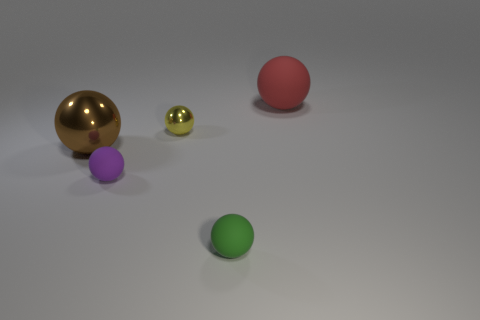Are there any other things that are the same material as the small yellow sphere?
Make the answer very short. Yes. The other tiny matte object that is the same shape as the small purple matte thing is what color?
Give a very brief answer. Green. Is the material of the red sphere the same as the big brown sphere?
Offer a very short reply. No. What number of tiny balls are the same color as the small metallic object?
Your answer should be compact. 0. Is the large metallic sphere the same color as the large rubber object?
Provide a short and direct response. No. What is the big ball that is on the right side of the brown shiny sphere made of?
Provide a succinct answer. Rubber. How many big objects are red rubber balls or purple things?
Provide a succinct answer. 1. Are there any brown objects made of the same material as the big red ball?
Keep it short and to the point. No. Do the rubber thing behind the purple sphere and the small green sphere have the same size?
Your answer should be compact. No. There is a large ball that is in front of the matte sphere that is right of the small green matte thing; are there any large red things behind it?
Ensure brevity in your answer.  Yes. 